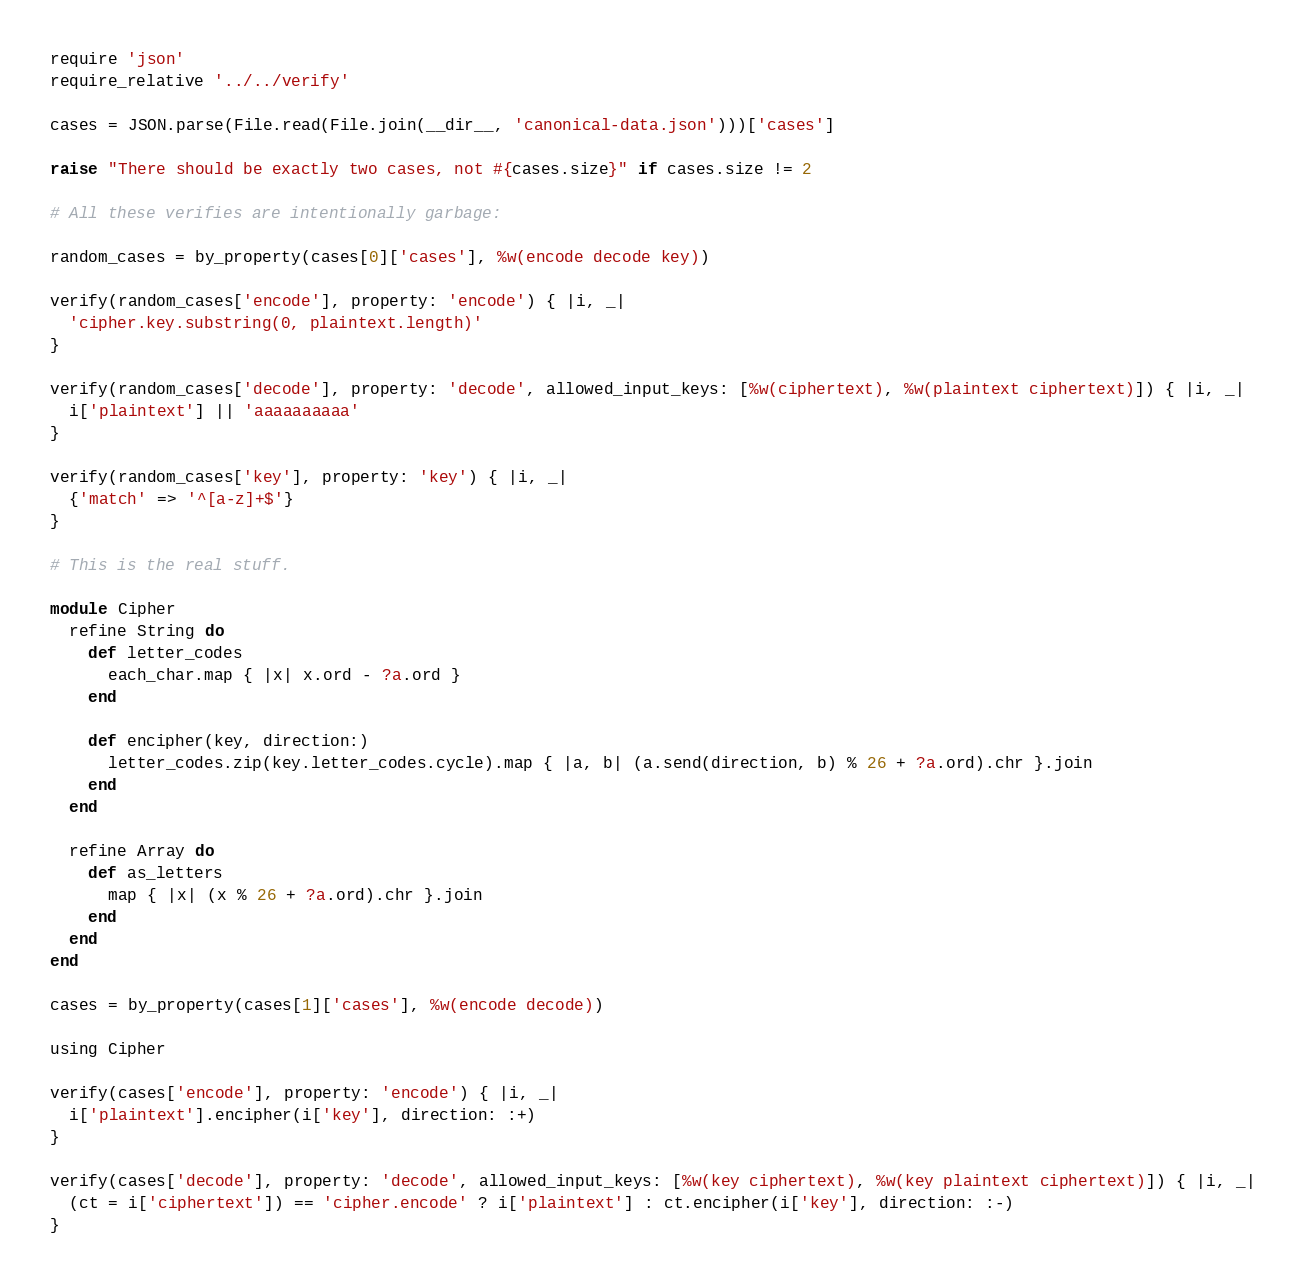Convert code to text. <code><loc_0><loc_0><loc_500><loc_500><_Ruby_>require 'json'
require_relative '../../verify'

cases = JSON.parse(File.read(File.join(__dir__, 'canonical-data.json')))['cases']

raise "There should be exactly two cases, not #{cases.size}" if cases.size != 2

# All these verifies are intentionally garbage:

random_cases = by_property(cases[0]['cases'], %w(encode decode key))

verify(random_cases['encode'], property: 'encode') { |i, _|
  'cipher.key.substring(0, plaintext.length)'
}

verify(random_cases['decode'], property: 'decode', allowed_input_keys: [%w(ciphertext), %w(plaintext ciphertext)]) { |i, _|
  i['plaintext'] || 'aaaaaaaaaa'
}

verify(random_cases['key'], property: 'key') { |i, _|
  {'match' => '^[a-z]+$'}
}

# This is the real stuff.

module Cipher
  refine String do
    def letter_codes
      each_char.map { |x| x.ord - ?a.ord }
    end

    def encipher(key, direction:)
      letter_codes.zip(key.letter_codes.cycle).map { |a, b| (a.send(direction, b) % 26 + ?a.ord).chr }.join
    end
  end

  refine Array do
    def as_letters
      map { |x| (x % 26 + ?a.ord).chr }.join
    end
  end
end

cases = by_property(cases[1]['cases'], %w(encode decode))

using Cipher

verify(cases['encode'], property: 'encode') { |i, _|
  i['plaintext'].encipher(i['key'], direction: :+)
}

verify(cases['decode'], property: 'decode', allowed_input_keys: [%w(key ciphertext), %w(key plaintext ciphertext)]) { |i, _|
  (ct = i['ciphertext']) == 'cipher.encode' ? i['plaintext'] : ct.encipher(i['key'], direction: :-)
}
</code> 